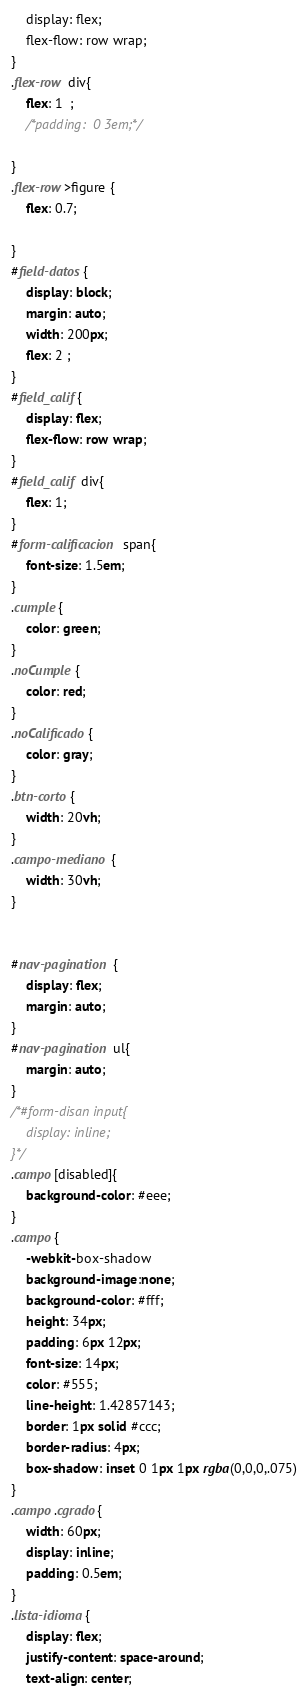<code> <loc_0><loc_0><loc_500><loc_500><_CSS_>	display: flex;
	flex-flow: row wrap;
}
.flex-row div{
	flex: 1  ;
	/*padding:  0 3em;*/

}
.flex-row>figure {
	flex: 0.7;

}
#field-datos{
	display: block;
	margin: auto;
	width: 200px;
	flex: 2 ;
}
#field_calif{
	display: flex;
	flex-flow: row wrap;
}
#field_calif div{
	flex: 1;
}
#form-calificacion span{
	font-size: 1.5em;
}
.cumple{
	color: green;
}
.noCumple{
	color: red;
}
.noCalificado{
	color: gray;
}
.btn-corto{
	width: 20vh;
}
.campo-mediano{
	width: 30vh;
}


#nav-pagination {
	display: flex;
	margin: auto;
}
#nav-pagination ul{
	margin: auto;
}
/*#form-disan input{
	display: inline;
}*/
.campo[disabled]{
	background-color: #eee;
}
.campo{
	-webkit-box-shadow
	background-image:none;
	background-color: #fff;
	height: 34px;
	padding: 6px 12px;
	font-size: 14px;
	color: #555;
	line-height: 1.42857143;
	border: 1px solid #ccc;
	border-radius: 4px;
	box-shadow: inset 0 1px 1px rgba(0,0,0,.075)
}
.campo.cgrado{
	width: 60px;
	display: inline;
	padding: 0.5em;
}
.lista-idioma{
	display: flex;
	justify-content: space-around;
	text-align: center;</code> 